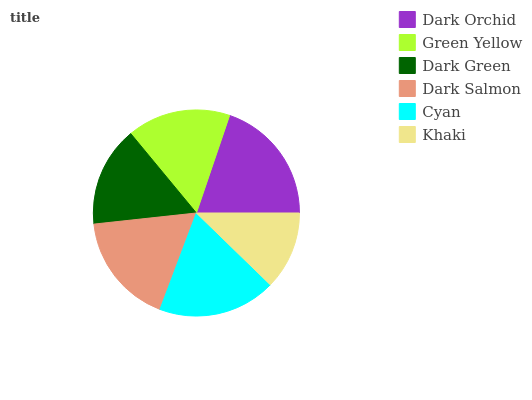Is Khaki the minimum?
Answer yes or no. Yes. Is Dark Orchid the maximum?
Answer yes or no. Yes. Is Green Yellow the minimum?
Answer yes or no. No. Is Green Yellow the maximum?
Answer yes or no. No. Is Dark Orchid greater than Green Yellow?
Answer yes or no. Yes. Is Green Yellow less than Dark Orchid?
Answer yes or no. Yes. Is Green Yellow greater than Dark Orchid?
Answer yes or no. No. Is Dark Orchid less than Green Yellow?
Answer yes or no. No. Is Dark Salmon the high median?
Answer yes or no. Yes. Is Green Yellow the low median?
Answer yes or no. Yes. Is Dark Green the high median?
Answer yes or no. No. Is Cyan the low median?
Answer yes or no. No. 